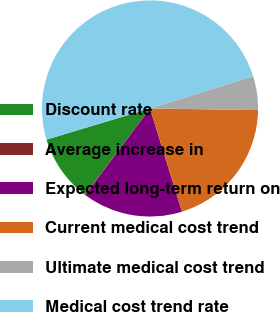Convert chart to OTSL. <chart><loc_0><loc_0><loc_500><loc_500><pie_chart><fcel>Discount rate<fcel>Average increase in<fcel>Expected long-term return on<fcel>Current medical cost trend<fcel>Ultimate medical cost trend<fcel>Medical cost trend rate<nl><fcel>10.03%<fcel>0.09%<fcel>15.01%<fcel>19.98%<fcel>5.06%<fcel>49.83%<nl></chart> 